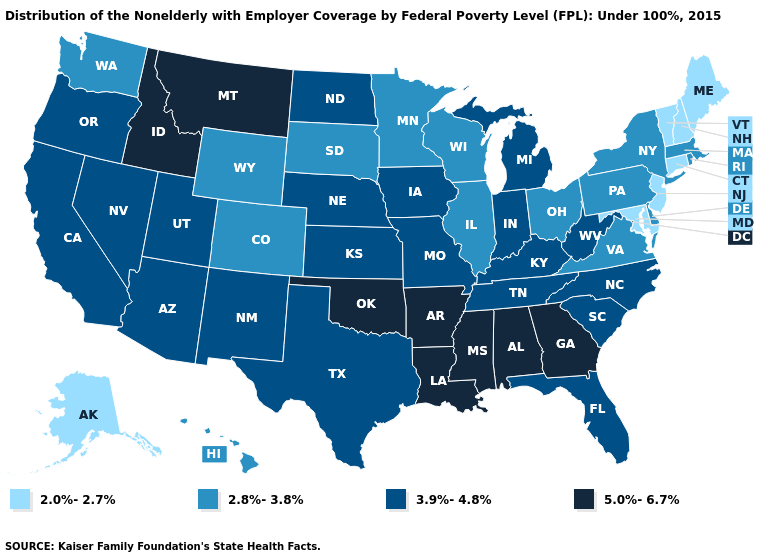Name the states that have a value in the range 2.8%-3.8%?
Quick response, please. Colorado, Delaware, Hawaii, Illinois, Massachusetts, Minnesota, New York, Ohio, Pennsylvania, Rhode Island, South Dakota, Virginia, Washington, Wisconsin, Wyoming. Which states hav the highest value in the West?
Concise answer only. Idaho, Montana. What is the highest value in states that border New York?
Concise answer only. 2.8%-3.8%. Does New Hampshire have a lower value than Nebraska?
Keep it brief. Yes. What is the value of Nevada?
Give a very brief answer. 3.9%-4.8%. Which states have the lowest value in the USA?
Give a very brief answer. Alaska, Connecticut, Maine, Maryland, New Hampshire, New Jersey, Vermont. Does South Dakota have the same value as Minnesota?
Be succinct. Yes. Among the states that border Massachusetts , which have the highest value?
Answer briefly. New York, Rhode Island. Is the legend a continuous bar?
Be succinct. No. What is the lowest value in states that border Alabama?
Quick response, please. 3.9%-4.8%. Is the legend a continuous bar?
Short answer required. No. What is the value of Hawaii?
Give a very brief answer. 2.8%-3.8%. What is the value of Washington?
Short answer required. 2.8%-3.8%. What is the value of North Carolina?
Short answer required. 3.9%-4.8%. Which states hav the highest value in the South?
Write a very short answer. Alabama, Arkansas, Georgia, Louisiana, Mississippi, Oklahoma. 